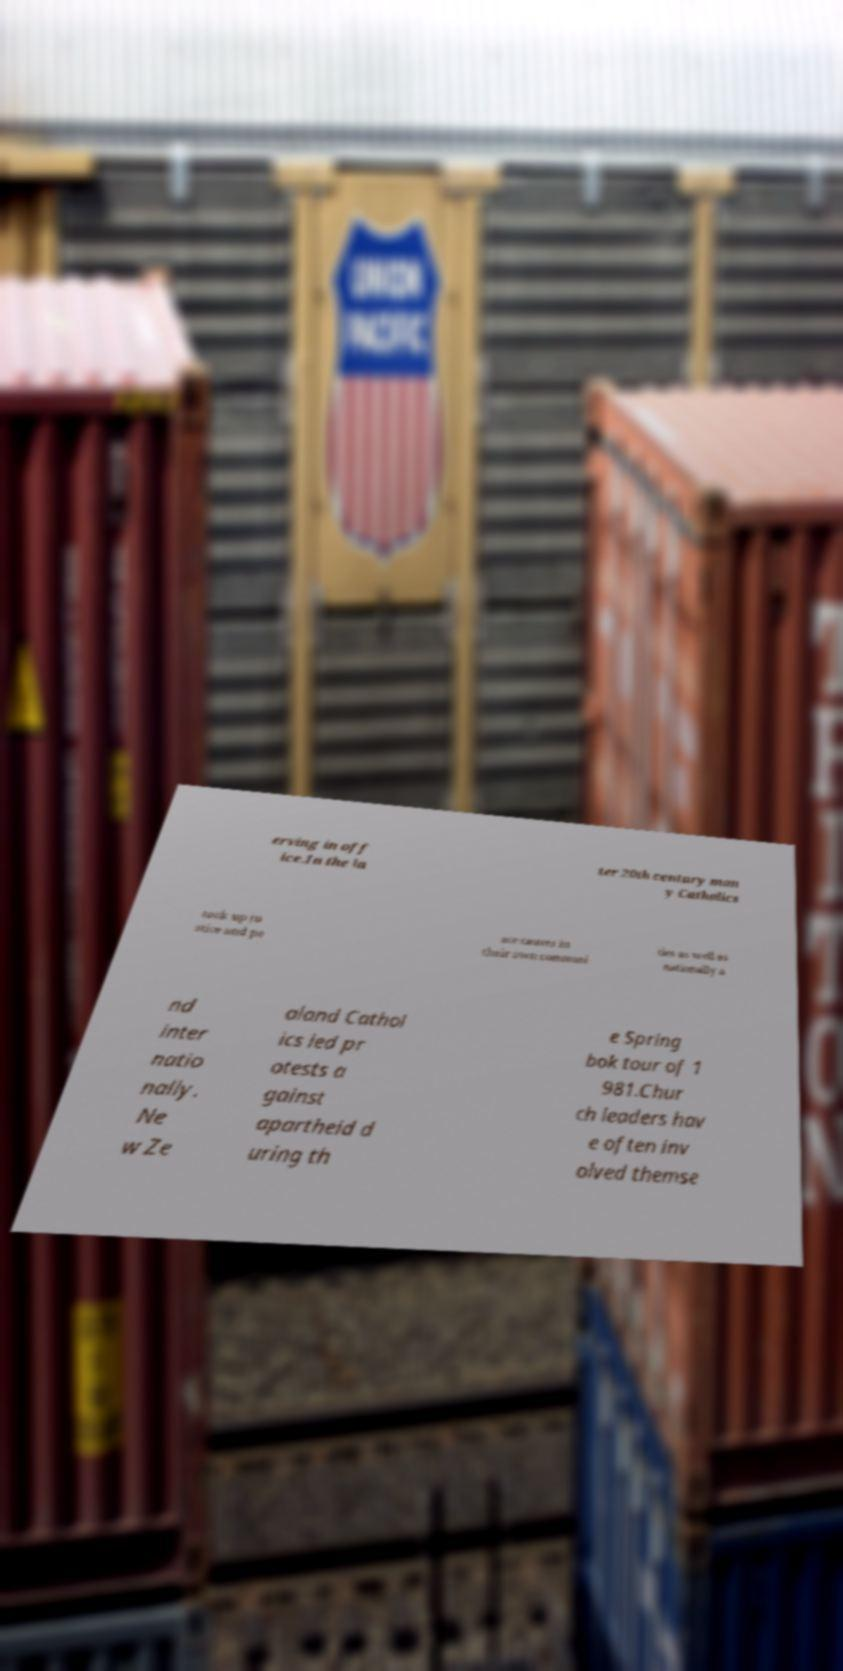I need the written content from this picture converted into text. Can you do that? erving in off ice.In the la ter 20th century man y Catholics took up ju stice and pe ace causes in their own communi ties as well as nationally a nd inter natio nally. Ne w Ze aland Cathol ics led pr otests a gainst apartheid d uring th e Spring bok tour of 1 981.Chur ch leaders hav e often inv olved themse 